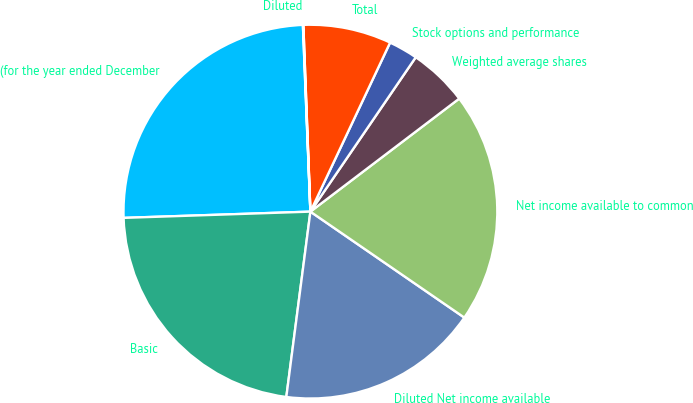Convert chart to OTSL. <chart><loc_0><loc_0><loc_500><loc_500><pie_chart><fcel>(for the year ended December<fcel>Basic<fcel>Diluted Net income available<fcel>Net income available to common<fcel>Weighted average shares<fcel>Stock options and performance<fcel>Total<fcel>Diluted<nl><fcel>24.89%<fcel>22.41%<fcel>17.46%<fcel>19.93%<fcel>5.13%<fcel>2.52%<fcel>7.61%<fcel>0.04%<nl></chart> 